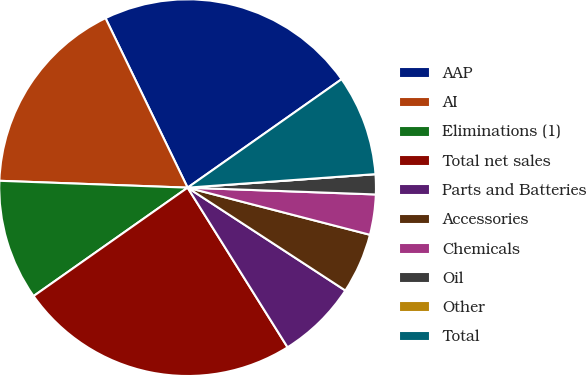Convert chart to OTSL. <chart><loc_0><loc_0><loc_500><loc_500><pie_chart><fcel>AAP<fcel>AI<fcel>Eliminations (1)<fcel>Total net sales<fcel>Parts and Batteries<fcel>Accessories<fcel>Chemicals<fcel>Oil<fcel>Other<fcel>Total<nl><fcel>22.41%<fcel>17.24%<fcel>10.34%<fcel>24.14%<fcel>6.9%<fcel>5.17%<fcel>3.45%<fcel>1.72%<fcel>0.0%<fcel>8.62%<nl></chart> 